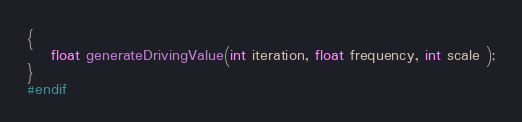Convert code to text. <code><loc_0><loc_0><loc_500><loc_500><_C_>{
	float generateDrivingValue(int iteration, float frequency, int scale );
}
#endif</code> 